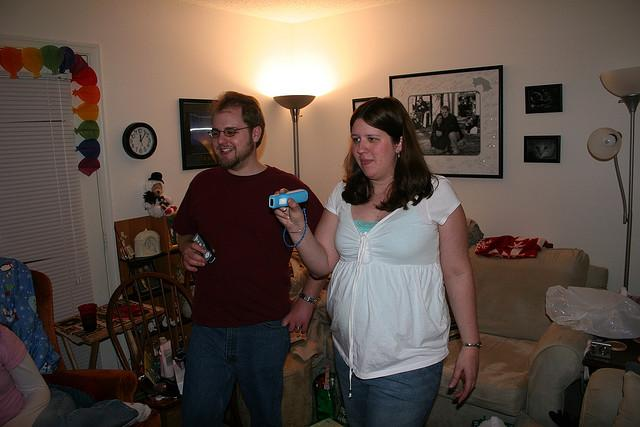What session of the day is it? night 